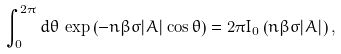<formula> <loc_0><loc_0><loc_500><loc_500>\int _ { 0 } ^ { 2 \pi } d \theta \, \exp \left ( - n \beta \sigma | A | \cos \theta \right ) = 2 \pi I _ { 0 } \left ( n \beta \sigma | A | \right ) ,</formula> 